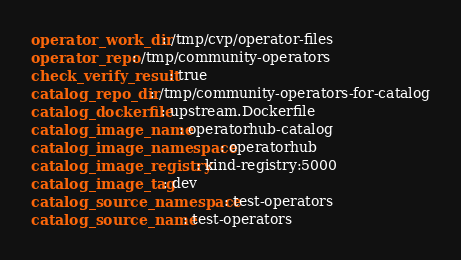<code> <loc_0><loc_0><loc_500><loc_500><_YAML_>operator_work_dir: /tmp/cvp/operator-files
operator_repo: /tmp/community-operators
check_verify_result: true
catalog_repo_dir: /tmp/community-operators-for-catalog
catalog_dockerfile: upstream.Dockerfile
catalog_image_name: operatorhub-catalog
catalog_image_namespace: operatorhub
catalog_image_registry: kind-registry:5000
catalog_image_tag: dev
catalog_source_namespace: test-operators
catalog_source_name: test-operators


</code> 